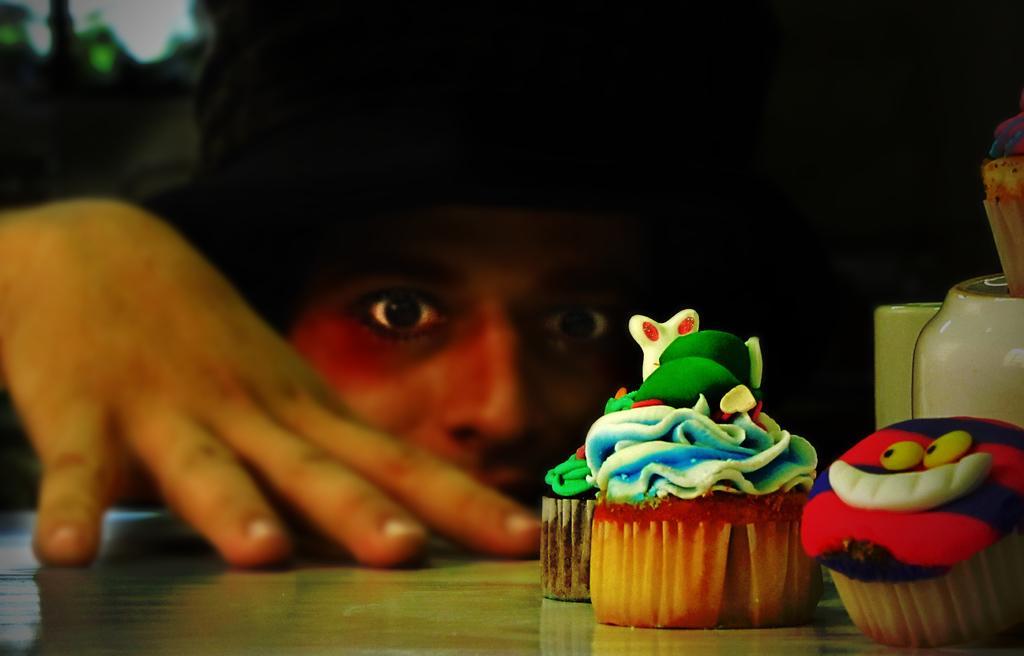Can you describe this image briefly? In this image the background is dark. At the bottom of the image there is a table. In the middle of the image there is a person. On the right side of the image there are a few cupcakes and there is a jar on the table. 